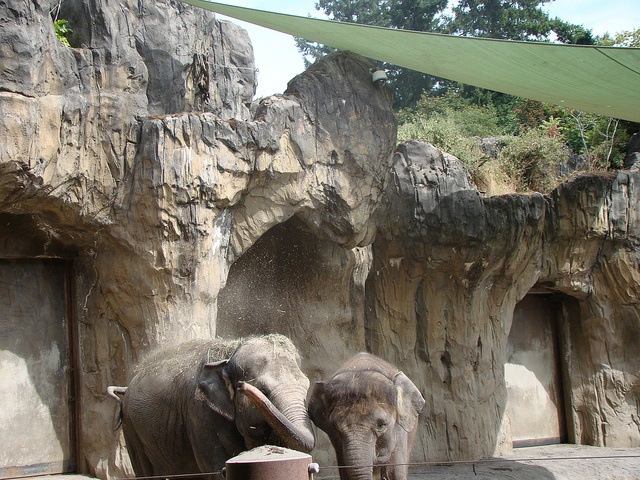Describe the objects in this image and their specific colors. I can see elephant in gray, black, darkgray, and lightgray tones and elephant in gray, darkgray, and black tones in this image. 